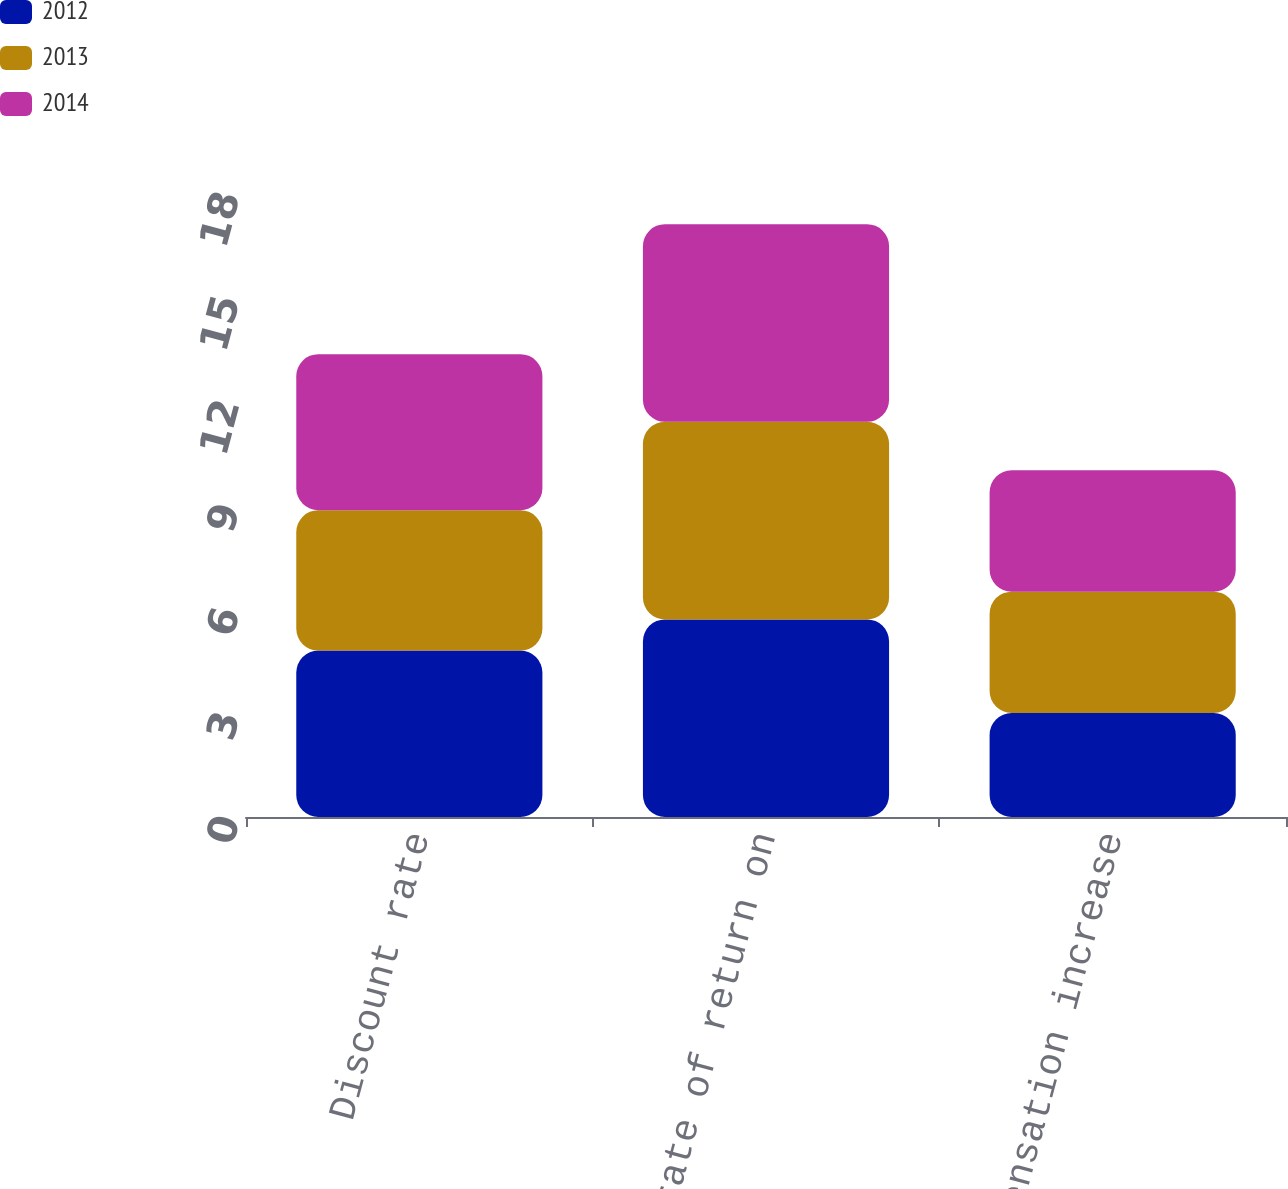Convert chart. <chart><loc_0><loc_0><loc_500><loc_500><stacked_bar_chart><ecel><fcel>Discount rate<fcel>Expected rate of return on<fcel>Rate of compensation increase<nl><fcel>2012<fcel>4.8<fcel>5.7<fcel>3<nl><fcel>2013<fcel>4.05<fcel>5.7<fcel>3.5<nl><fcel>2014<fcel>4.5<fcel>5.7<fcel>3.5<nl></chart> 